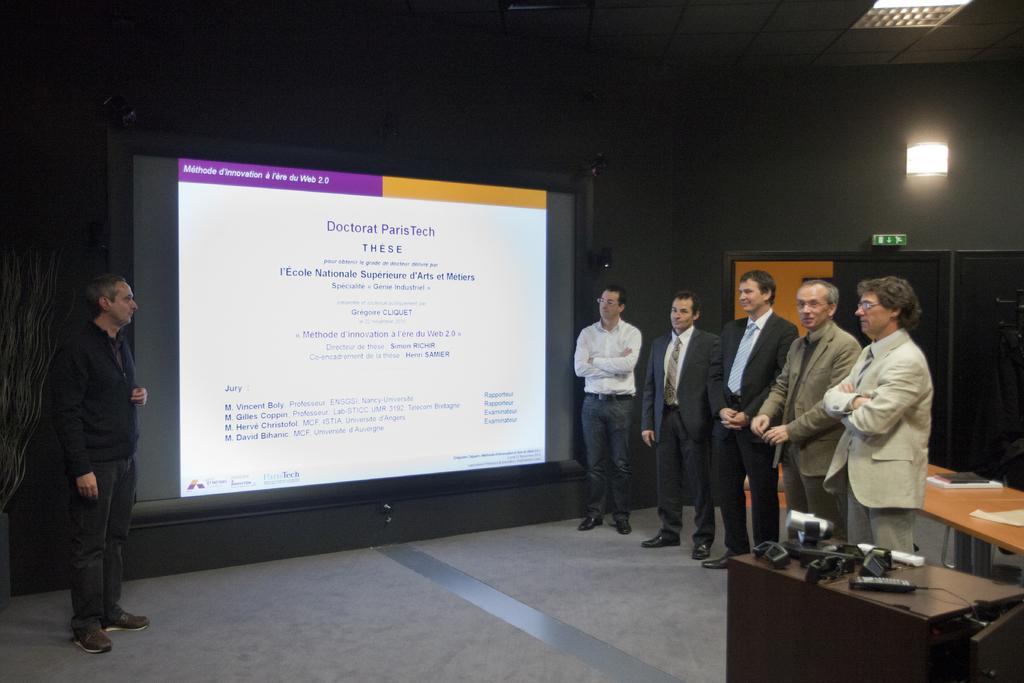Could you give a brief overview of what you see in this image? There are six man standing. This looks like a screen with a display. I can see a table with a remote, projector and few other objects on it. Here is another table with books and papers. This is a lamp, which is attached to the wall. I can see a door. This looks like an exit board. At the top of the image, I can see a ceiling light. 